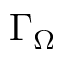<formula> <loc_0><loc_0><loc_500><loc_500>\Gamma _ { \Omega }</formula> 